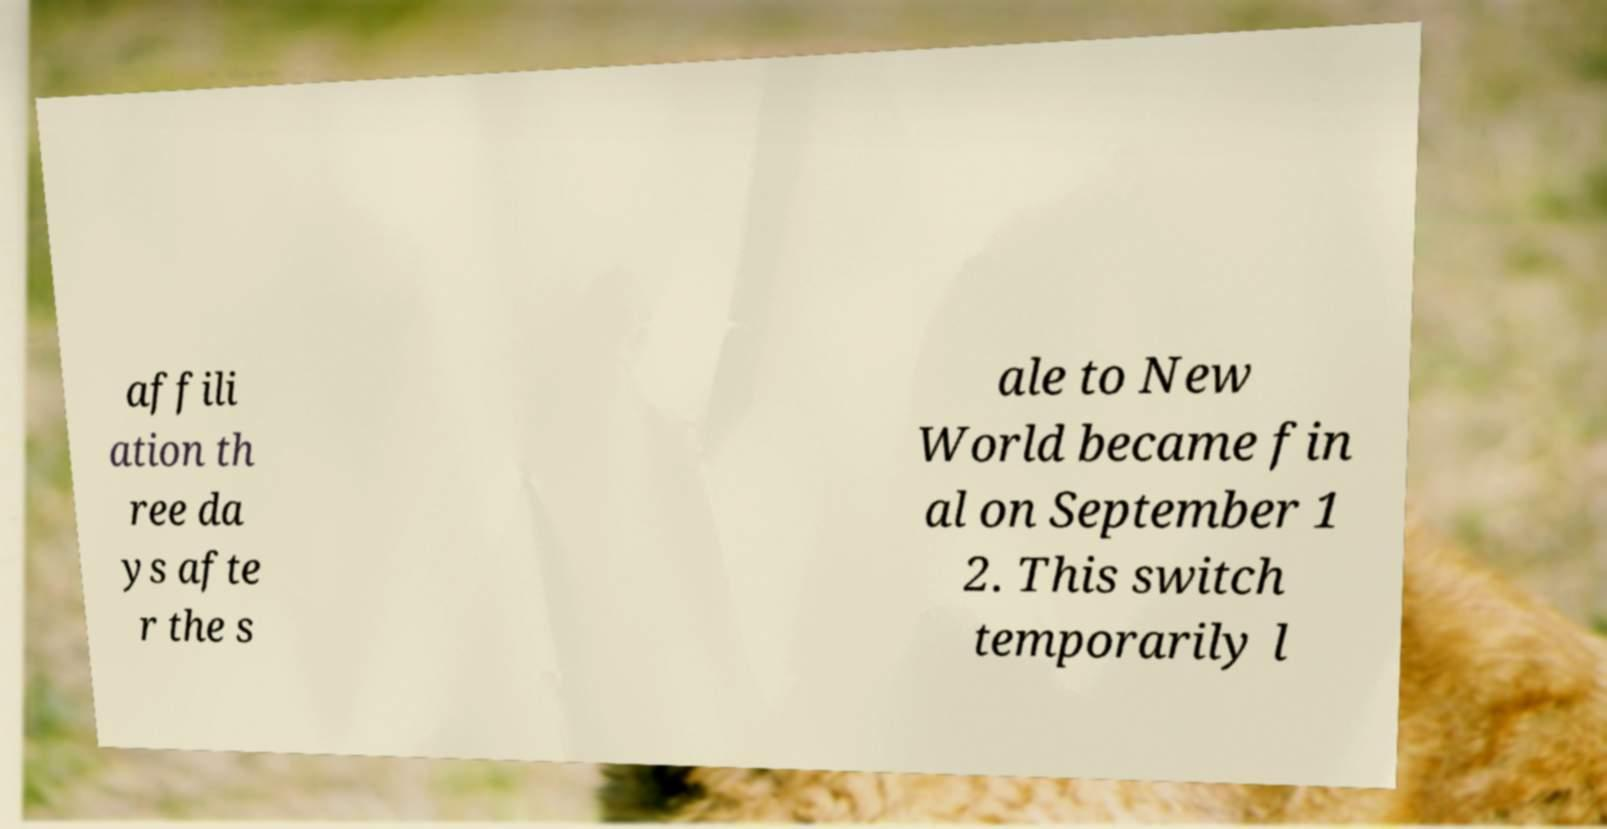I need the written content from this picture converted into text. Can you do that? affili ation th ree da ys afte r the s ale to New World became fin al on September 1 2. This switch temporarily l 